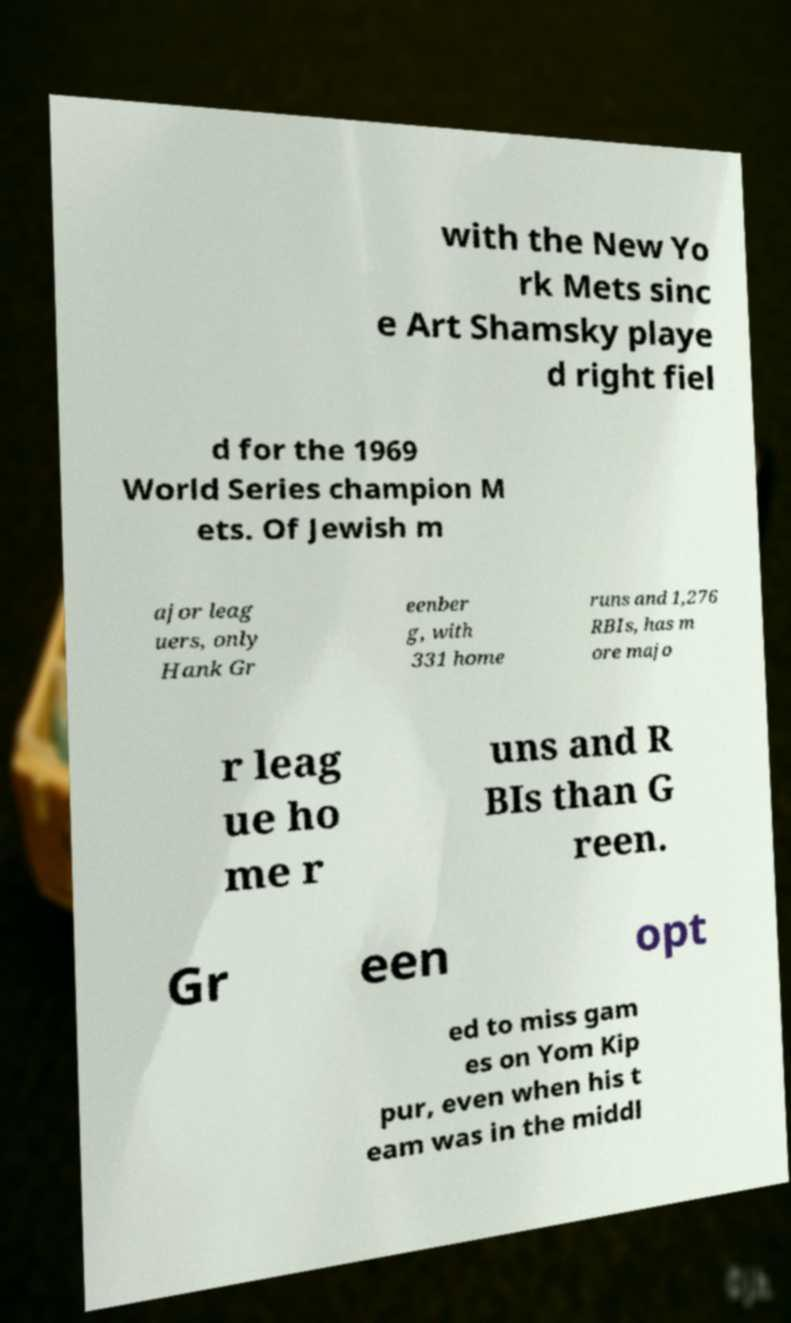What messages or text are displayed in this image? I need them in a readable, typed format. with the New Yo rk Mets sinc e Art Shamsky playe d right fiel d for the 1969 World Series champion M ets. Of Jewish m ajor leag uers, only Hank Gr eenber g, with 331 home runs and 1,276 RBIs, has m ore majo r leag ue ho me r uns and R BIs than G reen. Gr een opt ed to miss gam es on Yom Kip pur, even when his t eam was in the middl 